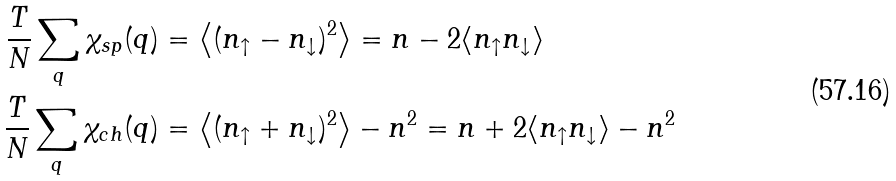<formula> <loc_0><loc_0><loc_500><loc_500>\frac { T } { N } \sum _ { q } \chi _ { s p } ( q ) & = \left \langle ( n _ { \uparrow } - n _ { \downarrow } ) ^ { 2 } \right \rangle = n - 2 \langle n _ { \uparrow } n _ { \downarrow } \rangle \\ \frac { T } { N } \sum _ { q } \chi _ { c h } ( q ) & = \left \langle ( n _ { \uparrow } + n _ { \downarrow } ) ^ { 2 } \right \rangle - n ^ { 2 } = n + 2 \langle n _ { \uparrow } n _ { \downarrow } \rangle - n ^ { 2 }</formula> 